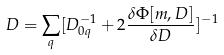Convert formula to latex. <formula><loc_0><loc_0><loc_500><loc_500>D = \sum _ { q } [ D _ { 0 q } ^ { - 1 } + 2 \frac { \delta \Phi [ m , D ] } { \delta D } ] ^ { - 1 }</formula> 